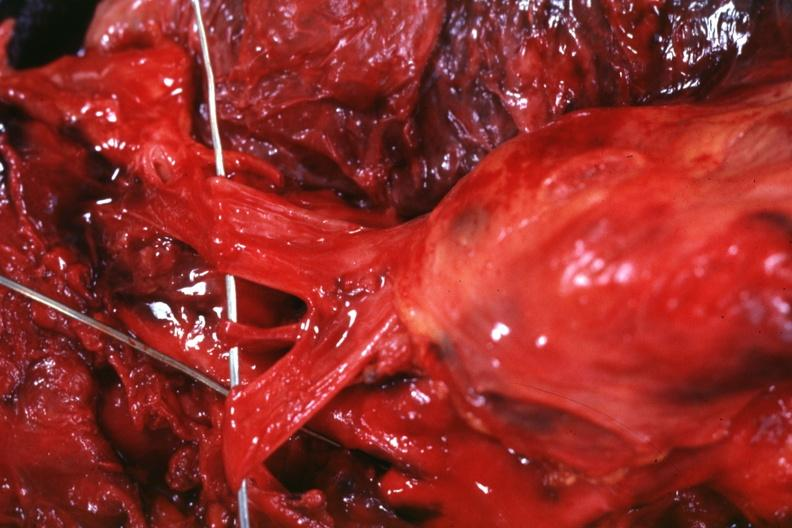s carcinomatosis present?
Answer the question using a single word or phrase. No 